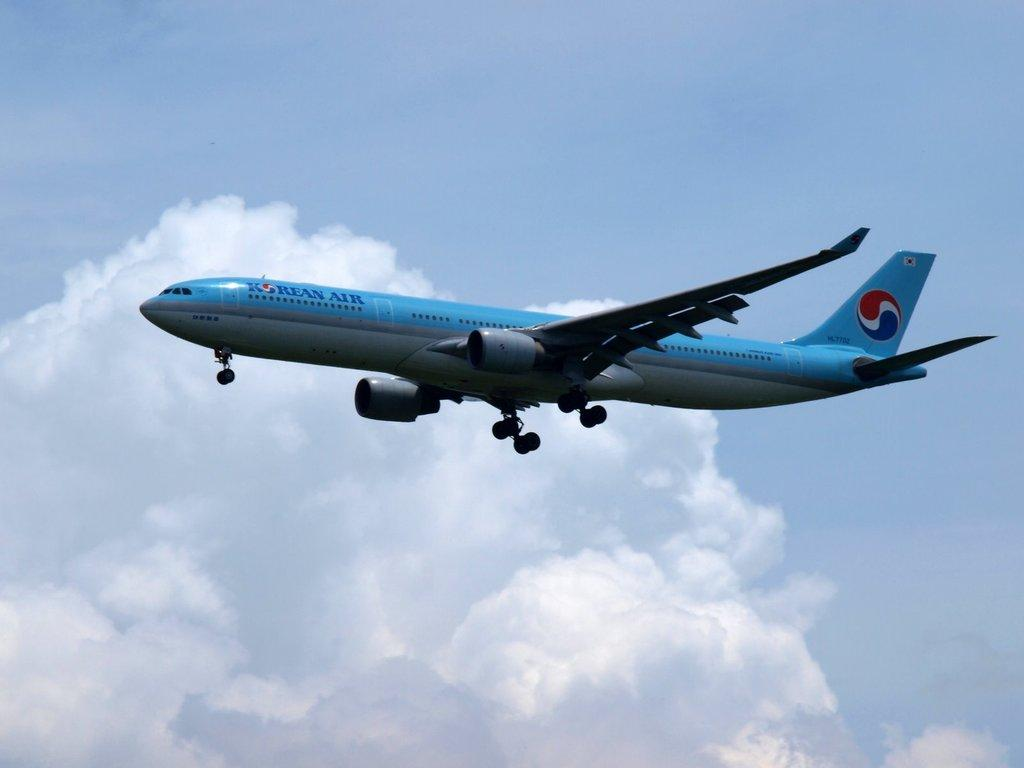<image>
Summarize the visual content of the image. a blue plan flying with the words Korean Air on it 